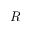Convert formula to latex. <formula><loc_0><loc_0><loc_500><loc_500>R</formula> 